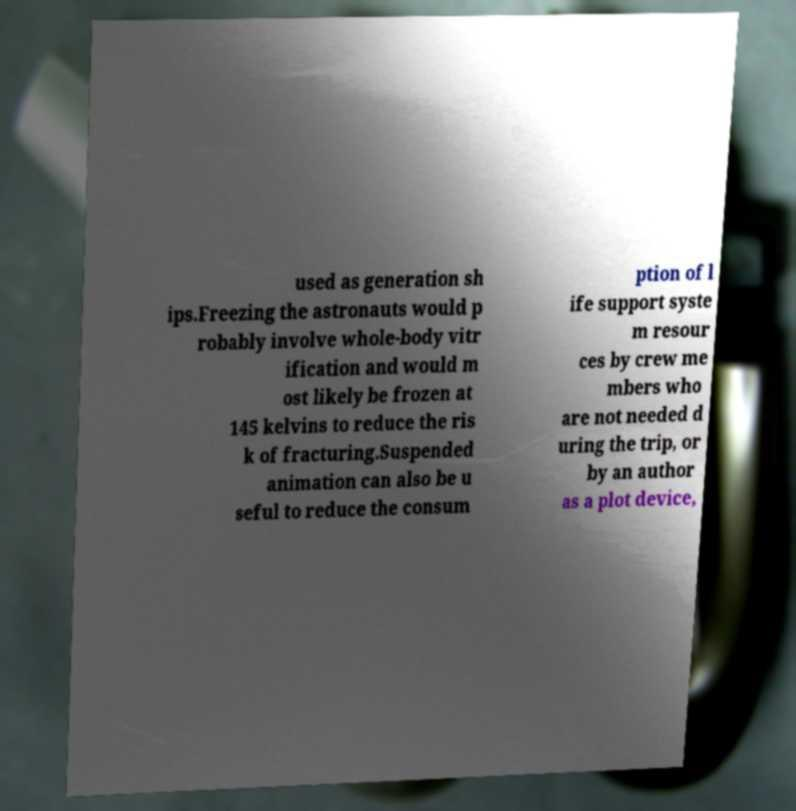Can you read and provide the text displayed in the image?This photo seems to have some interesting text. Can you extract and type it out for me? used as generation sh ips.Freezing the astronauts would p robably involve whole-body vitr ification and would m ost likely be frozen at 145 kelvins to reduce the ris k of fracturing.Suspended animation can also be u seful to reduce the consum ption of l ife support syste m resour ces by crew me mbers who are not needed d uring the trip, or by an author as a plot device, 